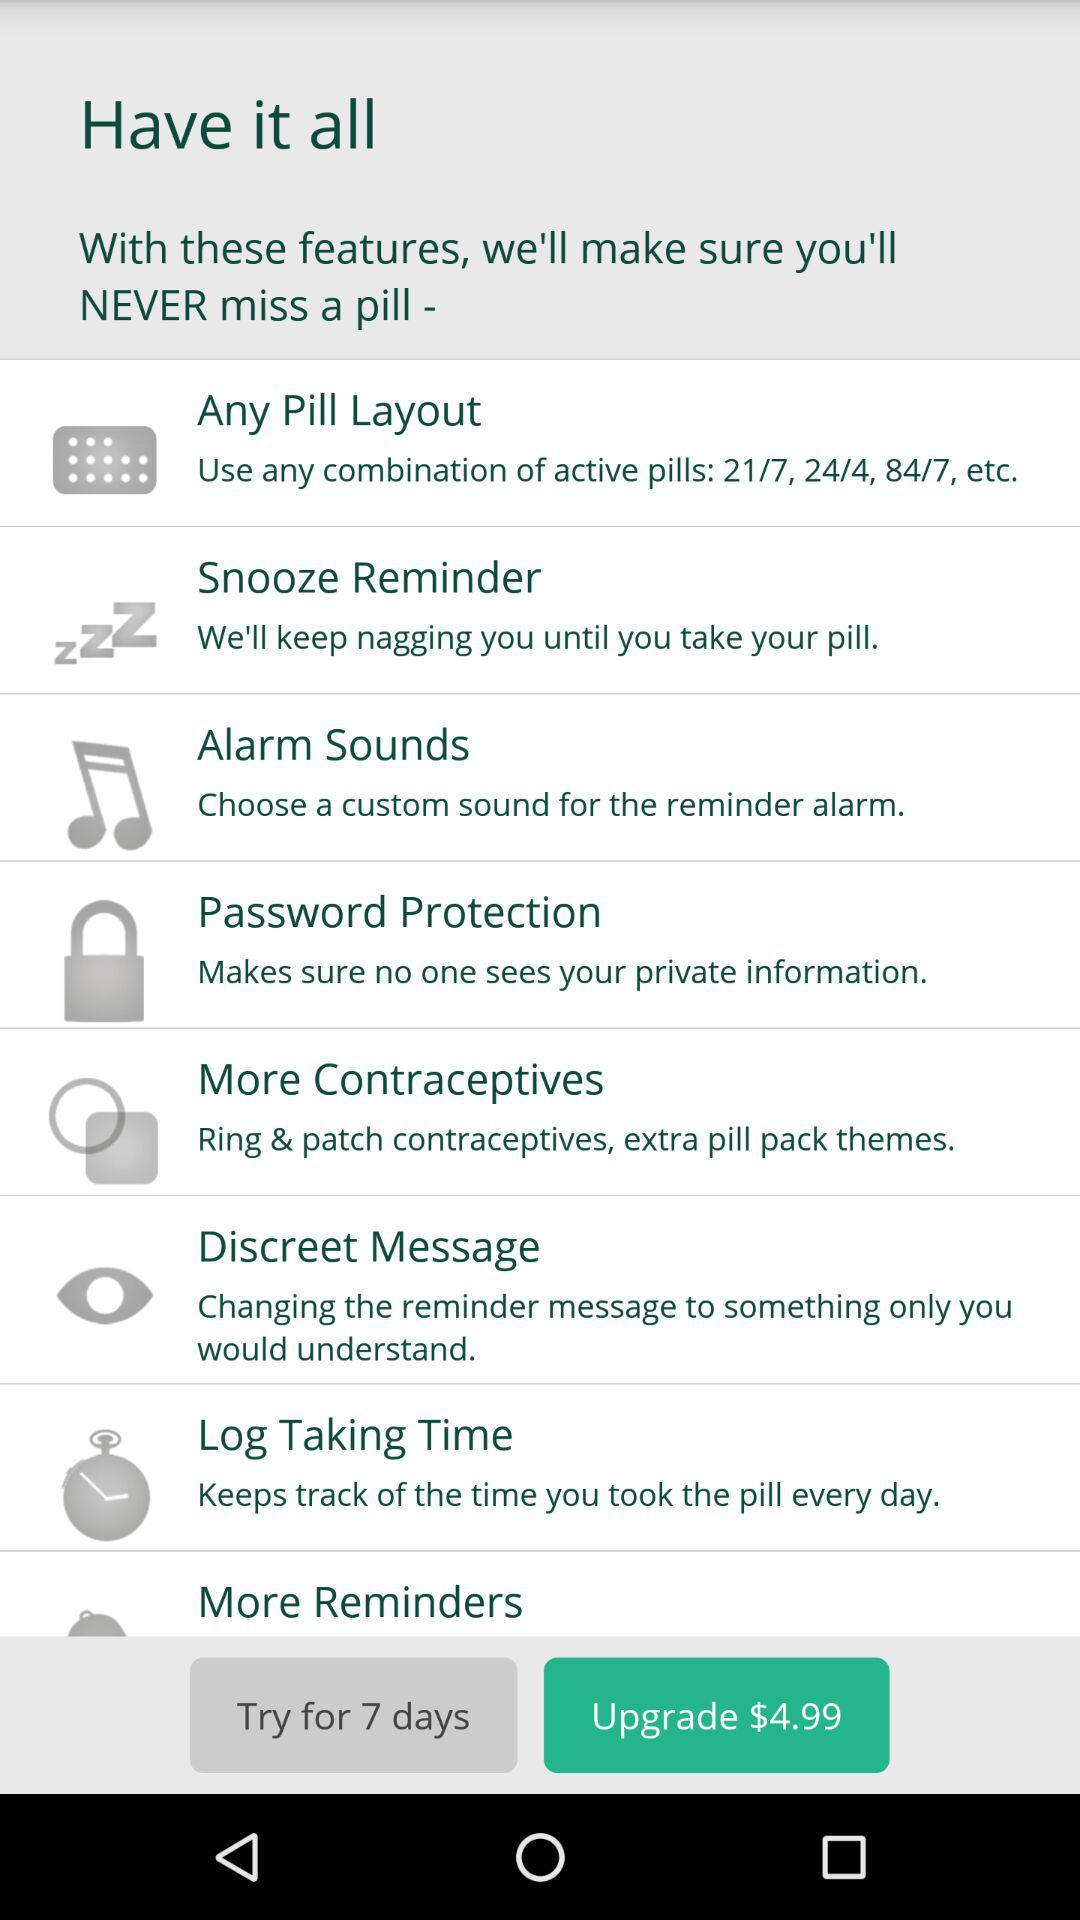How many days of trail are there? There are 7 days of trail. 